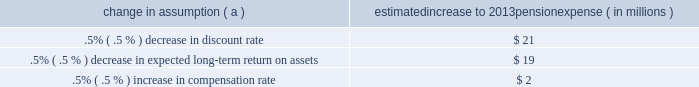Securities have historically returned approximately 10% ( 10 % ) annually over long periods of time , while u.s .
Debt securities have returned approximately 6% ( 6 % ) annually over long periods .
Application of these historical returns to the plan 2019s allocation ranges for equities and bonds produces a result between 7.25% ( 7.25 % ) and 8.75% ( 8.75 % ) and is one point of reference , among many other factors , that is taken into consideration .
We also examine the plan 2019s actual historical returns over various periods and consider the current economic environment .
Recent experience is considered in our evaluation with appropriate consideration that , especially for short time periods , recent returns are not reliable indicators of future returns .
While annual returns can vary significantly ( actual returns for 2012 , 2011 , and 2010 were +15.29% ( +15.29 % ) , +.11% ( +.11 % ) , and +14.87% ( +14.87 % ) , respectively ) , the selected assumption represents our estimated long-term average prospective returns .
Acknowledging the potentially wide range for this assumption , we also annually examine the assumption used by other companies with similar pension investment strategies , so that we can ascertain whether our determinations markedly differ from others .
In all cases , however , this data simply informs our process , which places the greatest emphasis on our qualitative judgment of future investment returns , given the conditions existing at each annual measurement date .
Taking into consideration all of these factors , the expected long-term return on plan assets for determining net periodic pension cost for 2012 was 7.75% ( 7.75 % ) , the same as it was for 2011 .
After considering the views of both internal and external capital market advisors , particularly with regard to the effects of the recent economic environment on long-term prospective fixed income returns , we are reducing our expected long-term return on assets to 7.50% ( 7.50 % ) for determining pension cost for under current accounting rules , the difference between expected long-term returns and actual returns is accumulated and amortized to pension expense over future periods .
Each one percentage point difference in actual return compared with our expected return causes expense in subsequent years to increase or decrease by up to $ 8 million as the impact is amortized into results of operations .
We currently estimate a pretax pension expense of $ 73 million in 2013 compared with pretax expense of $ 89 million in 2012 .
This year-over-year expected decrease reflects the impact of favorable returns on plan assets experienced in 2012 as well as the effects of the lower discount rate required to be used in the table below reflects the estimated effects on pension expense of certain changes in annual assumptions , using 2013 estimated expense as a baseline .
Table 27 : pension expense - sensitivity analysis change in assumption ( a ) estimated increase to 2013 pension expense ( in millions ) .
( a ) the impact is the effect of changing the specified assumption while holding all other assumptions constant .
Our pension plan contribution requirements are not particularly sensitive to actuarial assumptions .
Investment performance has the most impact on contribution requirements and will drive the amount of required contributions in future years .
Also , current law , including the provisions of the pension protection act of 2006 , sets limits as to both minimum and maximum contributions to the plan .
We do not expect to be required by law to make any contributions to the plan during 2013 .
We maintain other defined benefit plans that have a less significant effect on financial results , including various nonqualified supplemental retirement plans for certain employees , which are described more fully in note 15 employee benefit plans in the notes to consolidated financial statements in item 8 of this report .
The pnc financial services group , inc .
2013 form 10-k 77 .
For 2013 , did a .5% ( .5 % ) decrease in discount rate have a greater effect than a .5% ( .5 % ) decrease in expected long-term return on assets? 
Computations: (21 > 19)
Answer: yes. 